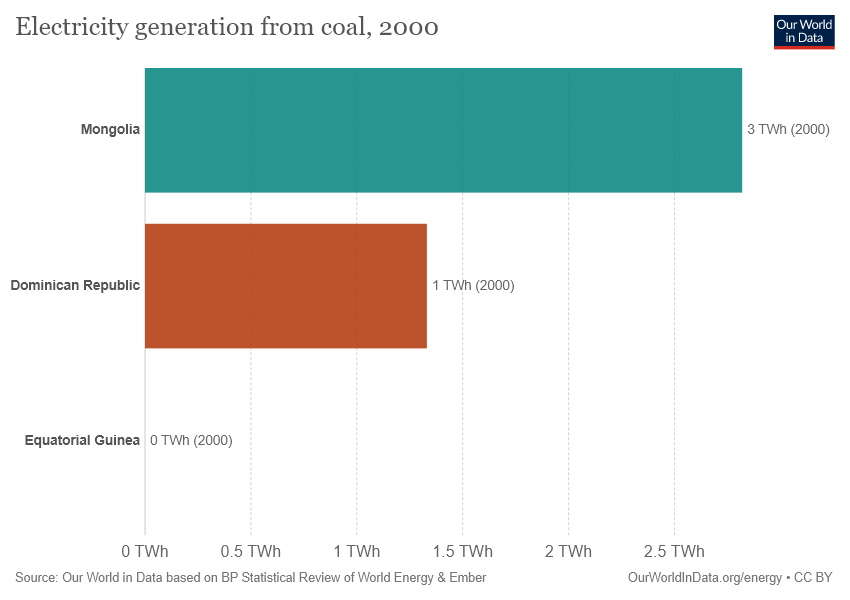Give some essential details in this illustration. The graph shows that electricity generation from coal in Mongolia was 3,000 megawatts in 2010, and increased to 7,000 megawatts in 2015. I have determined that the highest value and the average value differ by 1. 